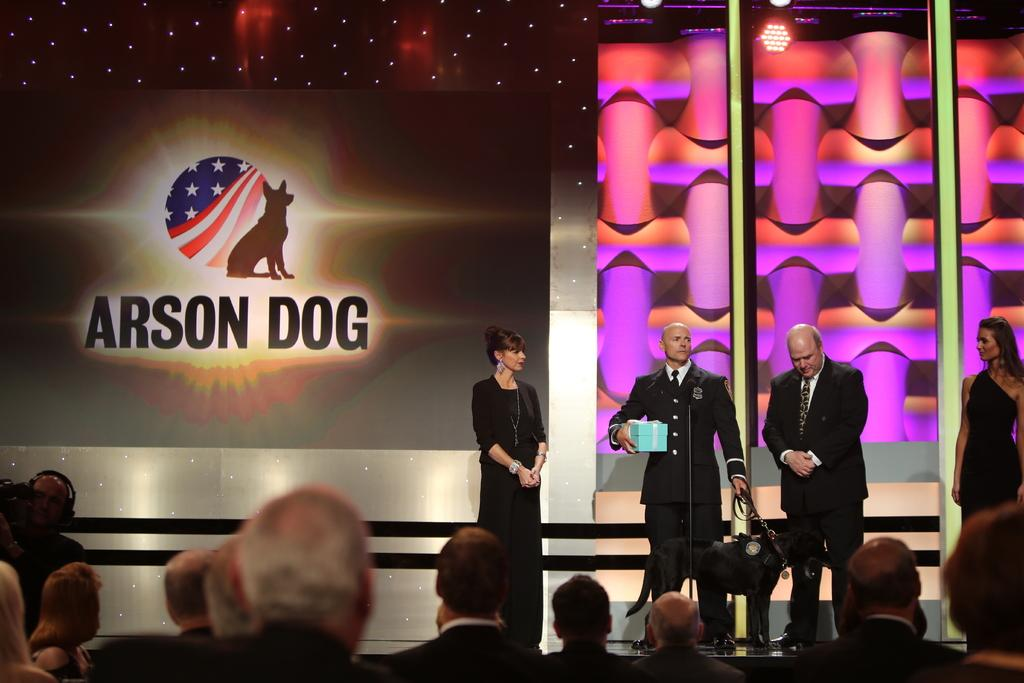<image>
Offer a succinct explanation of the picture presented. a huge projection screen behind some people that says 'arson dog' 